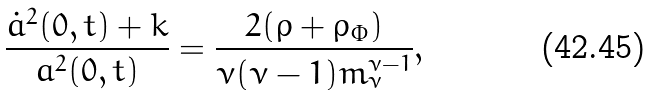<formula> <loc_0><loc_0><loc_500><loc_500>\frac { \dot { a } ^ { 2 } ( 0 , t ) + k } { a ^ { 2 } ( 0 , t ) } = \frac { 2 ( \rho + \rho _ { \Phi } ) } { \nu ( \nu - 1 ) m ^ { \nu - 1 } _ { \nu } } ,</formula> 